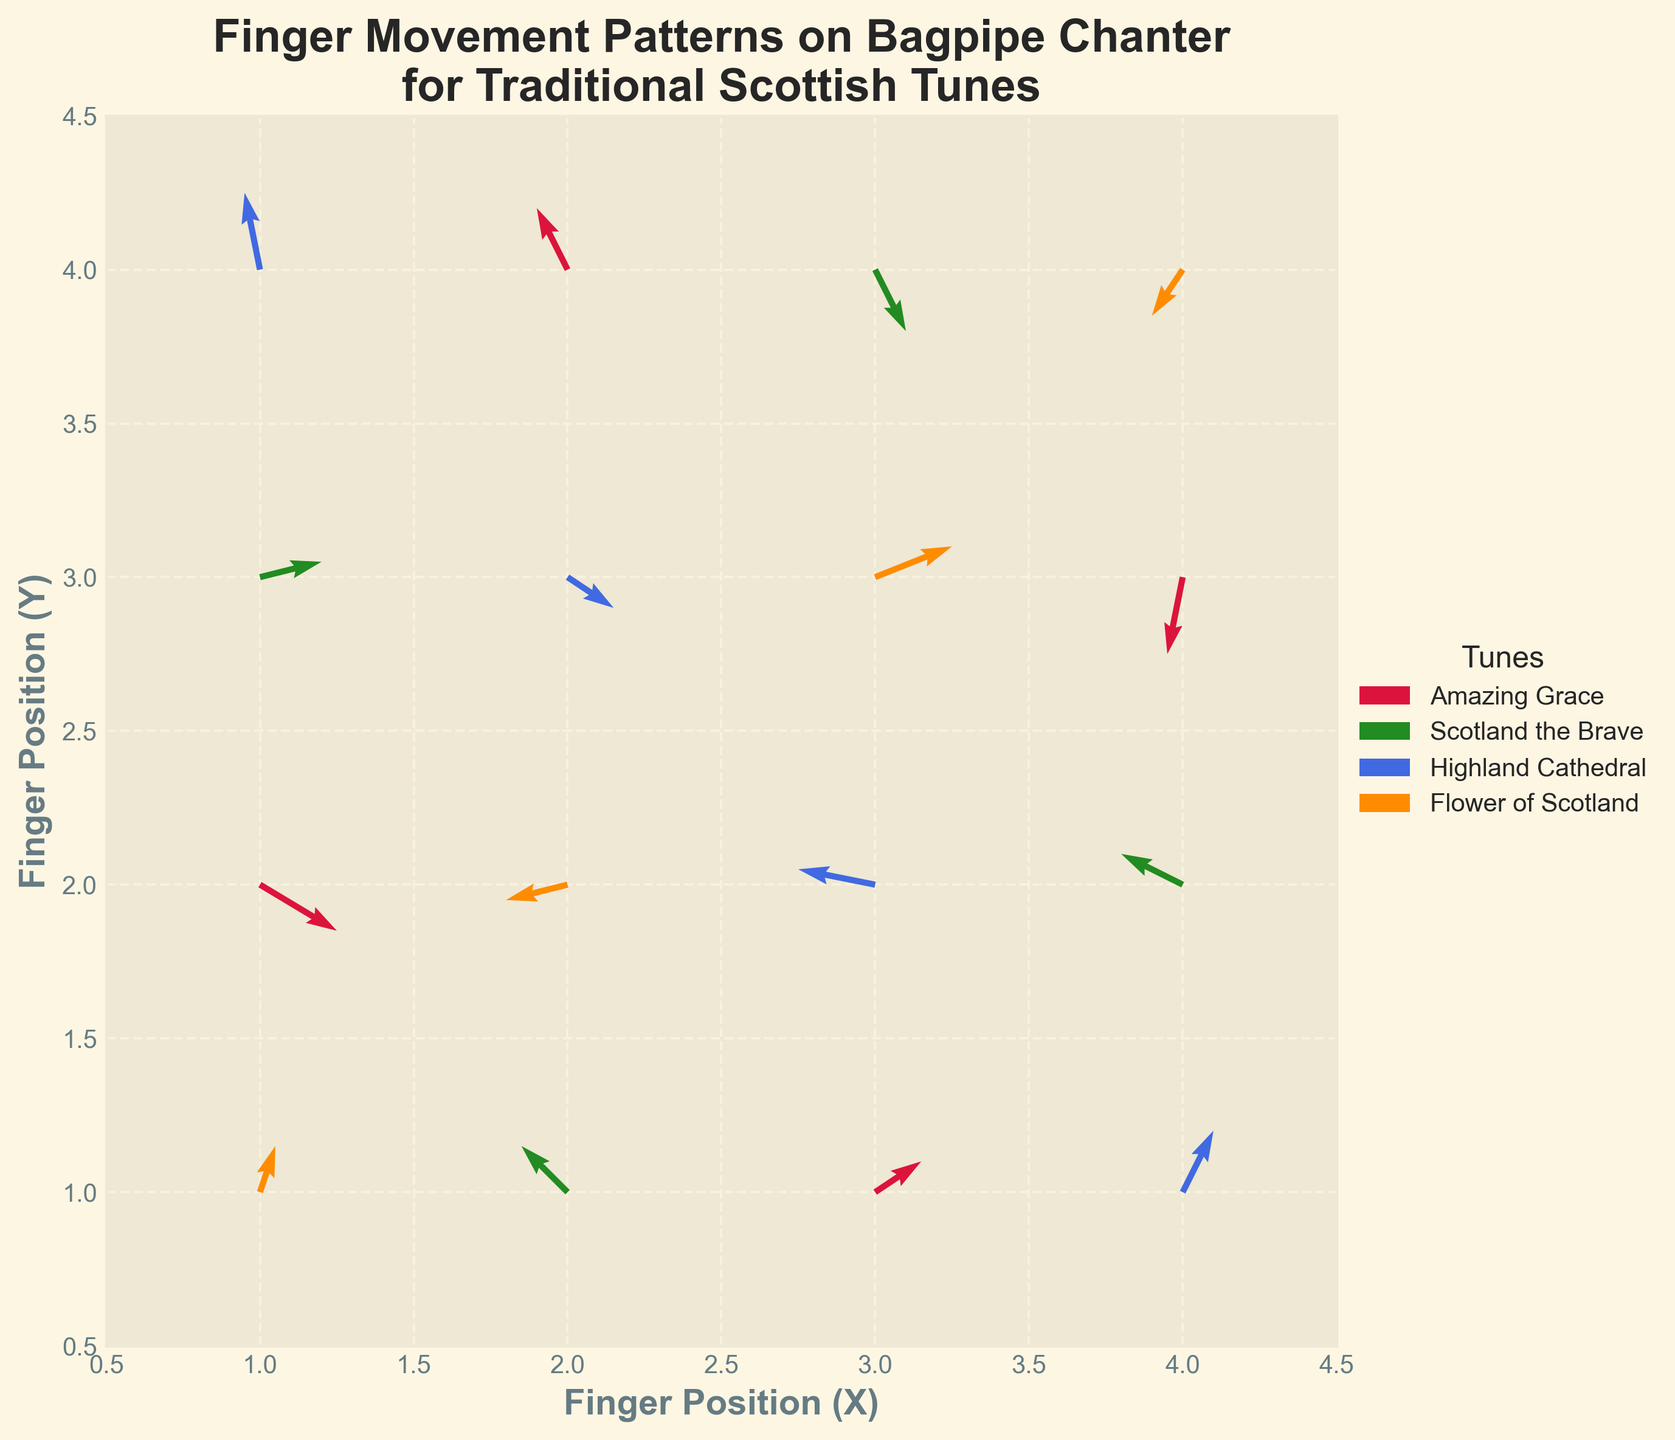What is the title of the figure? The title is written at the top center of the figure and says "Finger Movement Patterns on Bagpipe Chanter for Traditional Scottish Tunes".
Answer: Finger Movement Patterns on Bagpipe Chanter for Traditional Scottish Tunes What colors are used to represent different tunes? By looking at the legend, we can see that "Amazing Grace" is represented by crimson, "Scotland the Brave" by forestgreen, "Highland Cathedral" by royalblue, and "Flower of Scotland" by darkorange.
Answer: crimson, forestgreen, royalblue, darkorange What's the range of the x-axis and y-axis? The x-axis and y-axis range from 0.5 to 4.5, as indicated by the minimum and maximum values marked on both axes.
Answer: 0.5 to 4.5 How many data points are plotted for the tune "Amazing Grace"? The legend indicates colors for each tune, and by counting the arrows colored in crimson on the plot, we find there are 4 data points for "Amazing Grace".
Answer: 4 Which tune shows a finger movement starting from (1,1)? Checking the starting coordinates in the plot, the point (1,1) is associated with an arrow in darkorange, which corresponds to "Flower of Scotland" based on the legend.
Answer: Flower of Scotland How does the direction of movement for "Highland Cathedral" generally compare to "Amazing Grace"? Observing the plot, "Highland Cathedral" movements (in royalblue) typically point more vertically, while "Amazing Grace" movements (in crimson) vary with both horizontal and vertical components.
Answer: Vertical vs Mixed Does the tune "Scotland the Brave" exhibit more upward or downward movements? Analyzing the directions of arrows in forestgreen, "Scotland the Brave" has more upward movements than downward ones.
Answer: Upward What is the average u-component for the movements of "Flower of Scotland"? The u-components for "Flower of Scotland" are 0.1, -0.4, 0.5, -0.2. Adding these: 0.1 + (-0.4) + 0.5 + (-0.2) = 0, the average is 0 / 4 = 0.
Answer: 0 Which tune has the most varied finger movement directions? By comparing the arrows directionally, "Flower of Scotland" (darkorange) shows the widest variety in movement directions — upward, downward, left, and right.
Answer: Flower of Scotland How does the x-component of movement compare between "Scotland the Brave" and "Highland Cathedral"? For "Scotland the Brave," the x-components are 0.4, -0.3, 0.2, -0.4. For "Highland Cathedral," they are -0.1, 0.3, -0.5, 0.2. Calculating averages: 0.4 + (-0.3) + 0.2 + (-0.4) = -0.1, then -0.1/4 = -0.025 for "Scotland the Brave". While -0.1 + 0.3 + (-0.5) + 0.2 = -0.1, -0.1/4 = -0.025 for "Highland Cathedral". The average x-component for both is the same (-0.025).
Answer: Same 